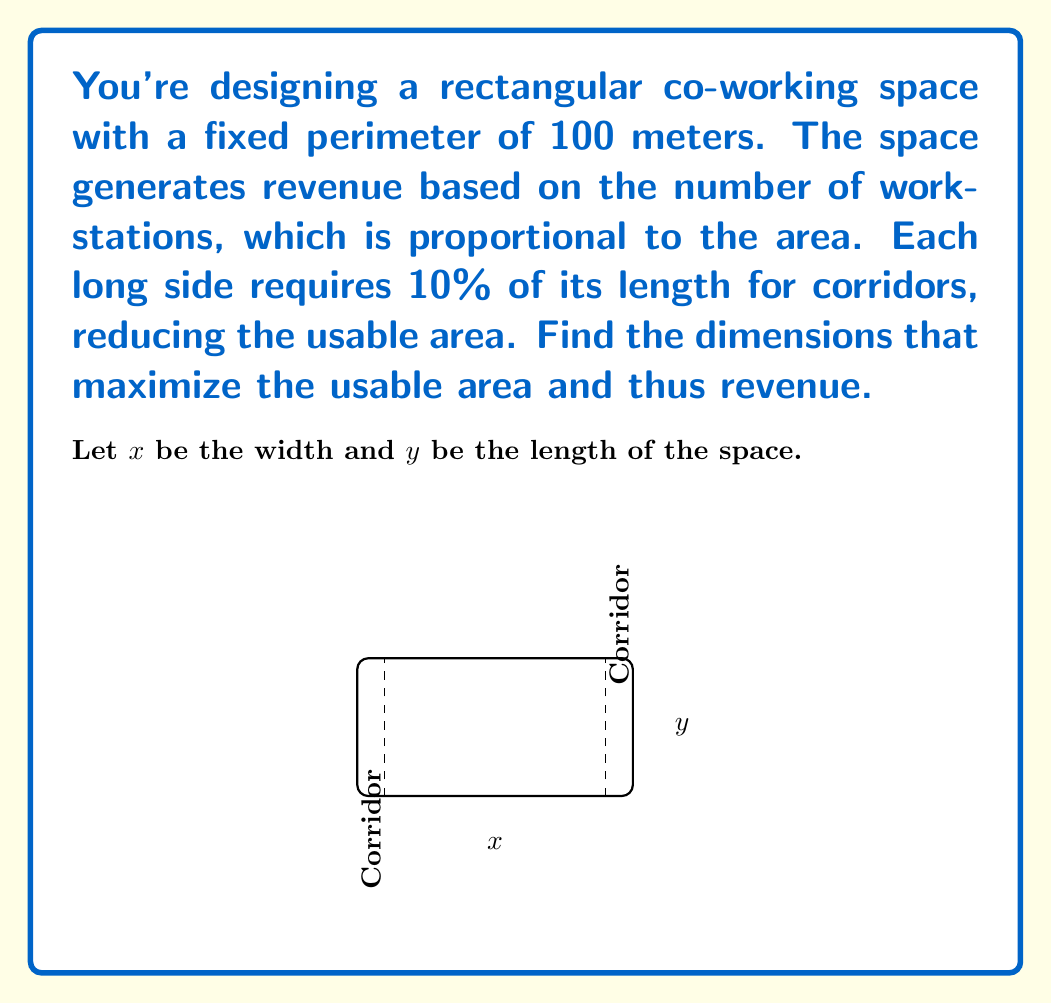Can you solve this math problem? Let's approach this step-by-step:

1) Given the perimeter is 100 meters, we can write:
   $2x + 2y = 100$
   $y = 50 - x$

2) The usable area $A$ is the total area minus the corridor areas:
   $A = xy - 0.1y(2x) = xy - 0.2xy = 0.8xy$

3) Substitute $y$ with $(50-x)$:
   $A = 0.8x(50-x) = 40x - 0.8x^2$

4) To find the maximum, we differentiate $A$ with respect to $x$ and set it to zero:
   $$\frac{dA}{dx} = 40 - 1.6x = 0$$

5) Solve for $x$:
   $40 - 1.6x = 0$
   $1.6x = 40$
   $x = 25$

6) The second derivative is negative ($-1.6$), confirming this is a maximum.

7) Calculate $y$:
   $y = 50 - x = 50 - 25 = 25$

8) The maximum usable area is:
   $A = 0.8xy = 0.8(25)(25) = 500$ square meters

Therefore, the optimal dimensions are 25m × 25m, creating a square shape.
Answer: 25m × 25m square; 500 m² usable area 